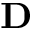<formula> <loc_0><loc_0><loc_500><loc_500>D</formula> 